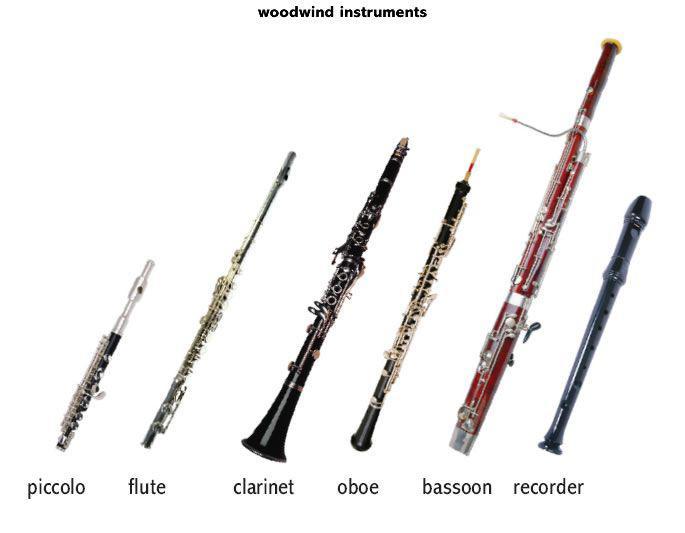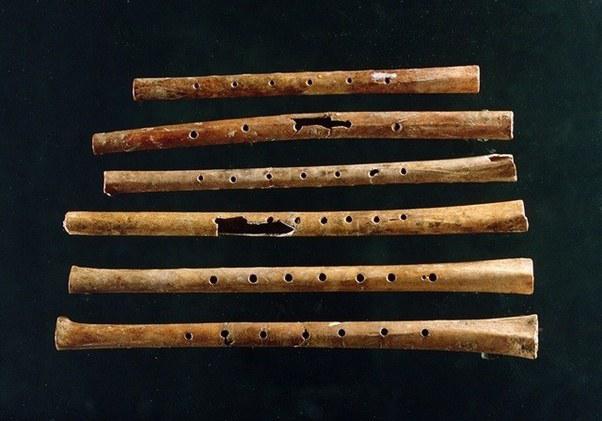The first image is the image on the left, the second image is the image on the right. Analyze the images presented: Is the assertion "There are at least  15 flutes that are white, black or brown sitting on  multiple shelves." valid? Answer yes or no. No. The first image is the image on the left, the second image is the image on the right. For the images shown, is this caption "An image contains various flute like instruments with an all white background." true? Answer yes or no. Yes. 